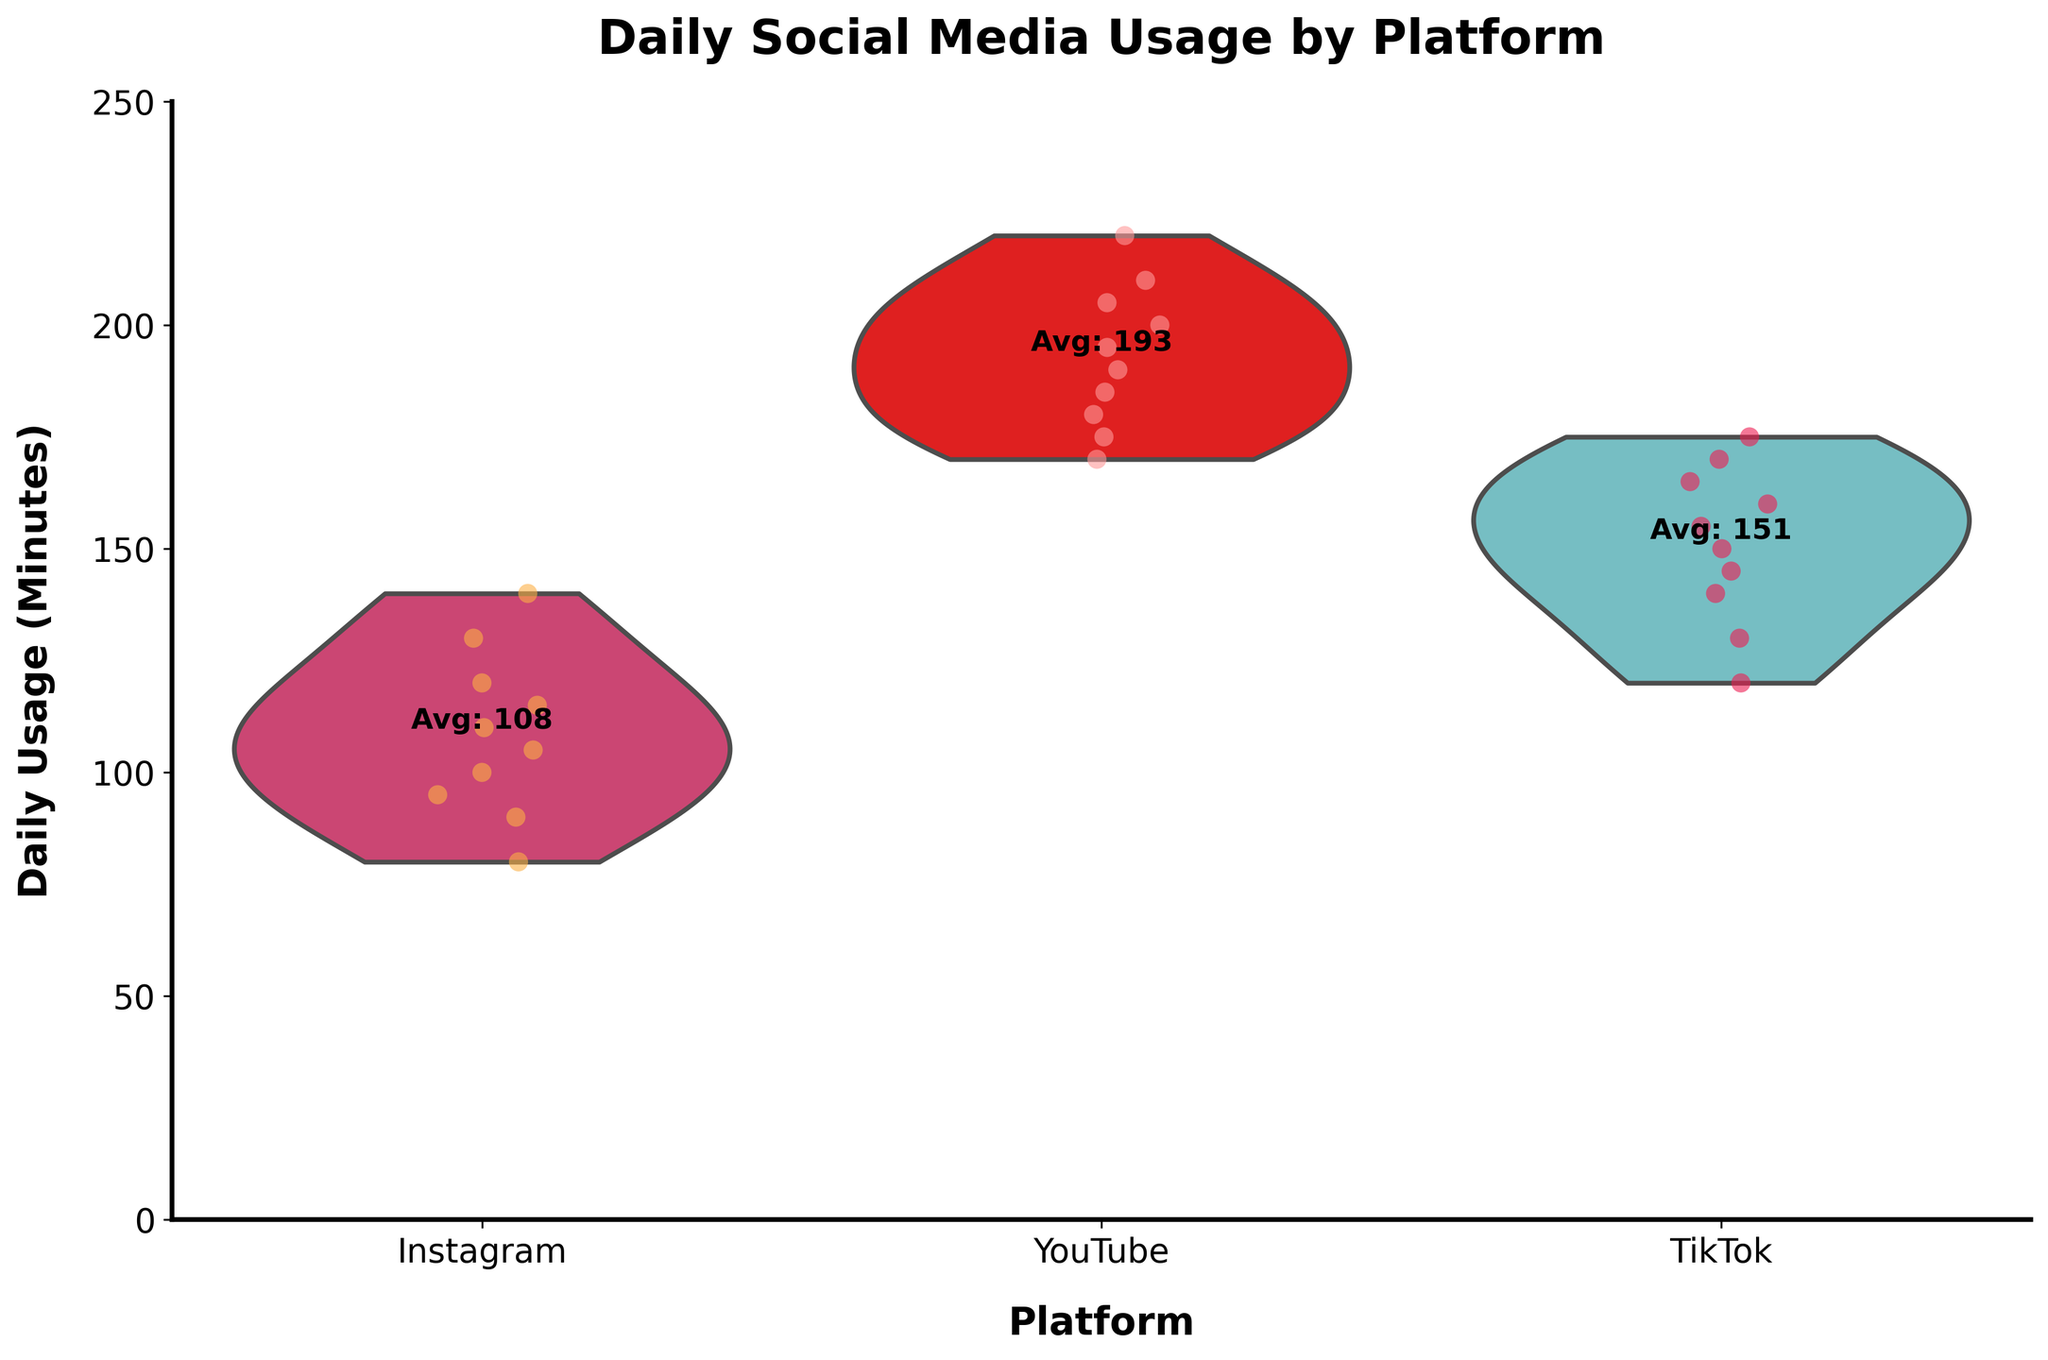what is the title of the figure? The title is the text at the top of the figure. It usually provides a summary of what the figure is about.
Answer: Daily Social Media Usage by Platform What is the average daily usage for Instagram? The average daily usage is shown as a text annotation on the plot directly above the "Instagram" category.
Answer: 108 How many minutes does the top YouTube user spend on the platform daily? By identifying the highest jittered point within the YouTube category, you can identify the maximum value.
Answer: 220 Which platform has the most varied daily usage time? The width and spread of the violin plot indicate the variance in daily usage times. The wider and more stretched the violin, the higher the variance.
Answer: Instagram Which platform has the highest average daily usage? By comparing the text annotations for average daily usage above each platform category, identify the highest value.
Answer: YouTube What is the range of daily usage minutes for TikTok users? The range can be determined by identifying the lowest and highest jittered points within the TikTok category.
Answer: 120-175 How does the average daily usage for TikTok compare to Instagram? Compare the average daily usage values annotated above the "TikTok" and "Instagram" categories.
Answer: TikTok's average usage is higher Which platform has the least variation in daily usage time? The violin plot with the narrowest spread indicates less variation.
Answer: YouTube What is the median daily usage for Instagram users? The median is shown within the violin plot, typically associated with the widest part of the plot vertically.
Answer: Approximately 105 minutes Which category has the highest jittered point? Identify the highest point among all the jittered points across all categories.
Answer: YouTube 